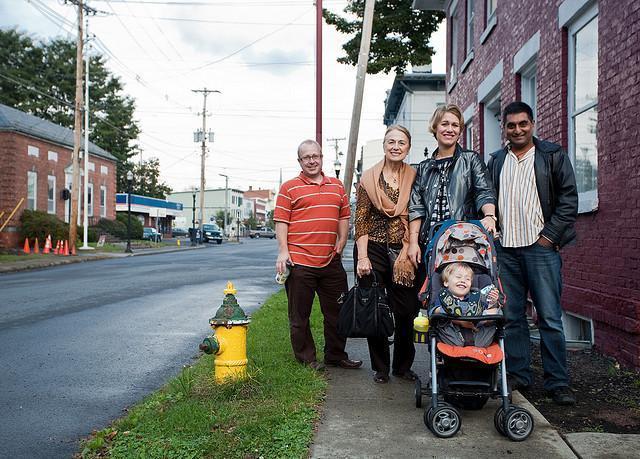How many women are in the picture?
Give a very brief answer. 2. How many people are in the photo?
Give a very brief answer. 5. How many benches are on the left of the room?
Give a very brief answer. 0. 